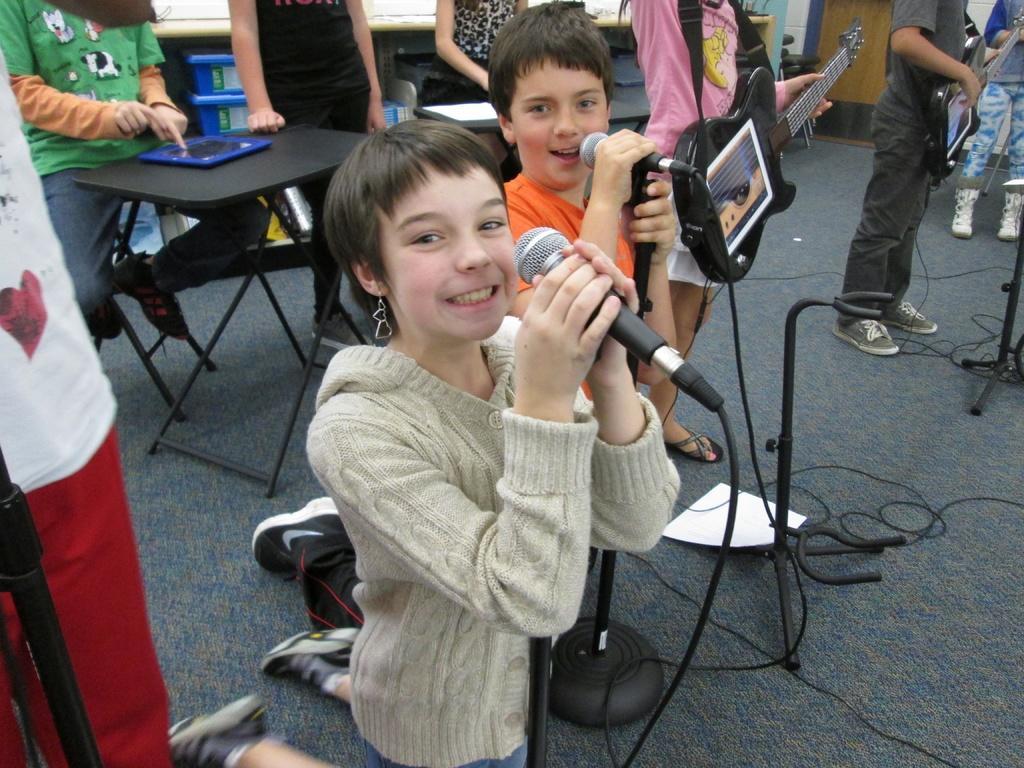Describe this image in one or two sentences. Girl and boy are singing together with microphones beside there is another person holding a guitar. 